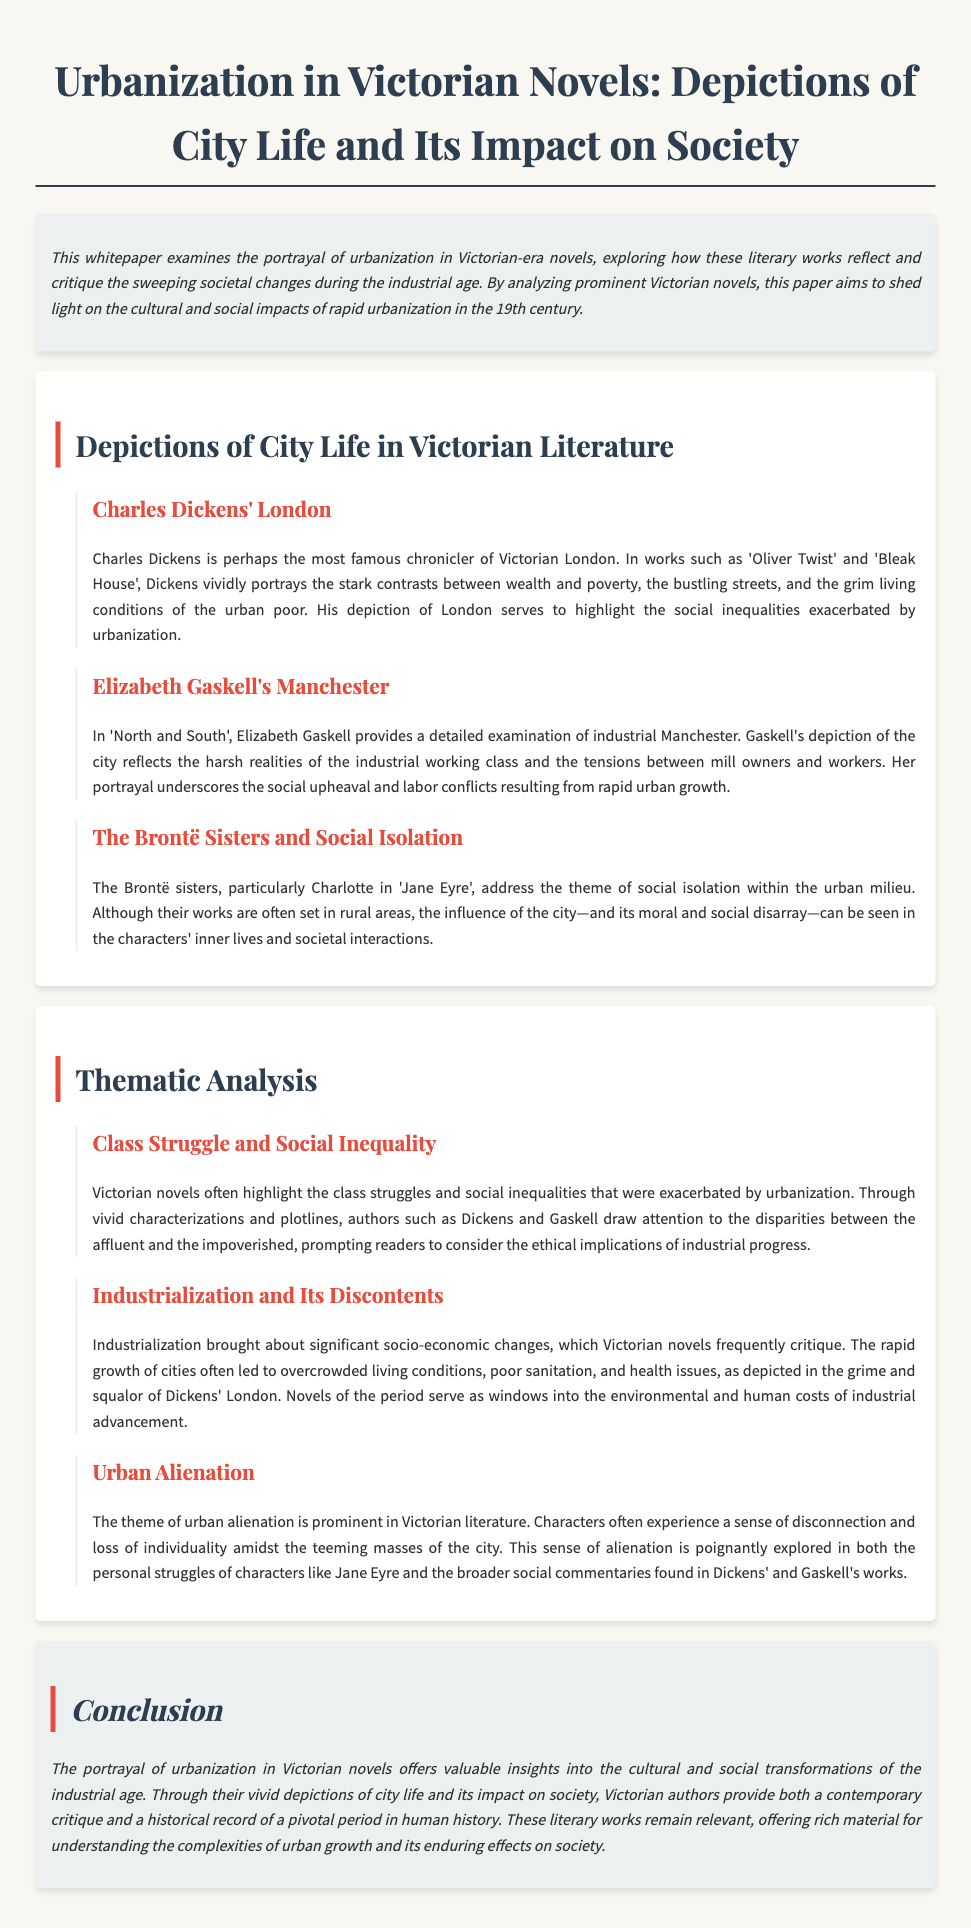What is the title of the whitepaper? The title is stated at the beginning of the document as the main header.
Answer: Urbanization in Victorian Novels: Depictions of City Life and Its Impact on Society Who is the author of 'Oliver Twist'? 'Oliver Twist' is a novel written by Charles Dickens, mentioned in the section discussing his work.
Answer: Charles Dickens Which city is primarily associated with Elizabeth Gaskell in the document? The document mentions Manchester as the city Gaskell focuses on in 'North and South'.
Answer: Manchester What theme do the Brontë sisters address in their novels? The document specifically states that the Brontë sisters discuss the theme of social isolation within the urban milieu.
Answer: Social isolation What socio-economic issue does the whitepaper highlight as prevalent in Victorian novels? The section on class struggle indicates that social inequalities are a key issue addressed in the literature of the time.
Answer: Class struggle In which novel is the character Jane Eyre featured? The character Jane Eyre is discussed in the context of the Brontë sisters' works.
Answer: Jane Eyre Which author is noted for depicting the grime and squalor of London? The document identifies Charles Dickens as the author known for this portrayal.
Answer: Charles Dickens What is a prominent theme related to urban life mentioned in the whitepaper? The document discusses urban alienation as a significant theme in Victorian literature.
Answer: Urban alienation What do Victorian novels serve as, according to the conclusion? The conclusion states that these novels provide a contemporary critique and a historical record.
Answer: Contemporary critique and historical record 